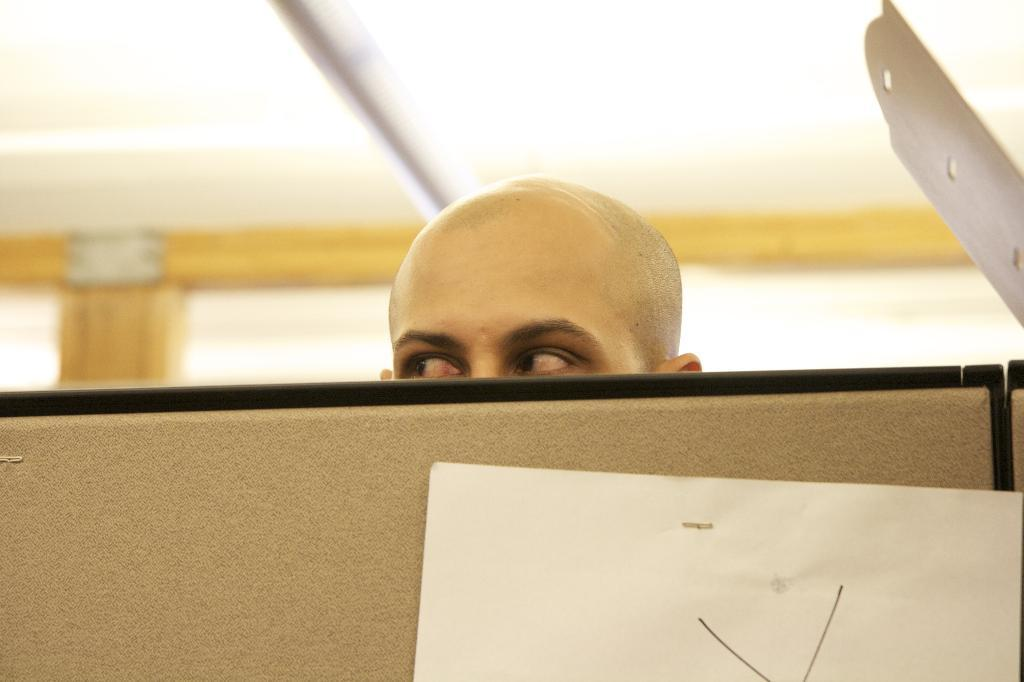What is the main subject in the center of the image? There is a human head in the center of the image. What is the board used for in the image? The board's purpose is not clear from the image, but it is present. What is placed on the board in the image? There is a paper on the board in the image. What object can be seen on the right side of the image? There is an object on the right side of the image, but its identity is not clear from the provided facts. How would you describe the background of the image? The background of the image is blurred. What type of dust can be seen on the quartz in the image? There is no dust or quartz present in the image. 